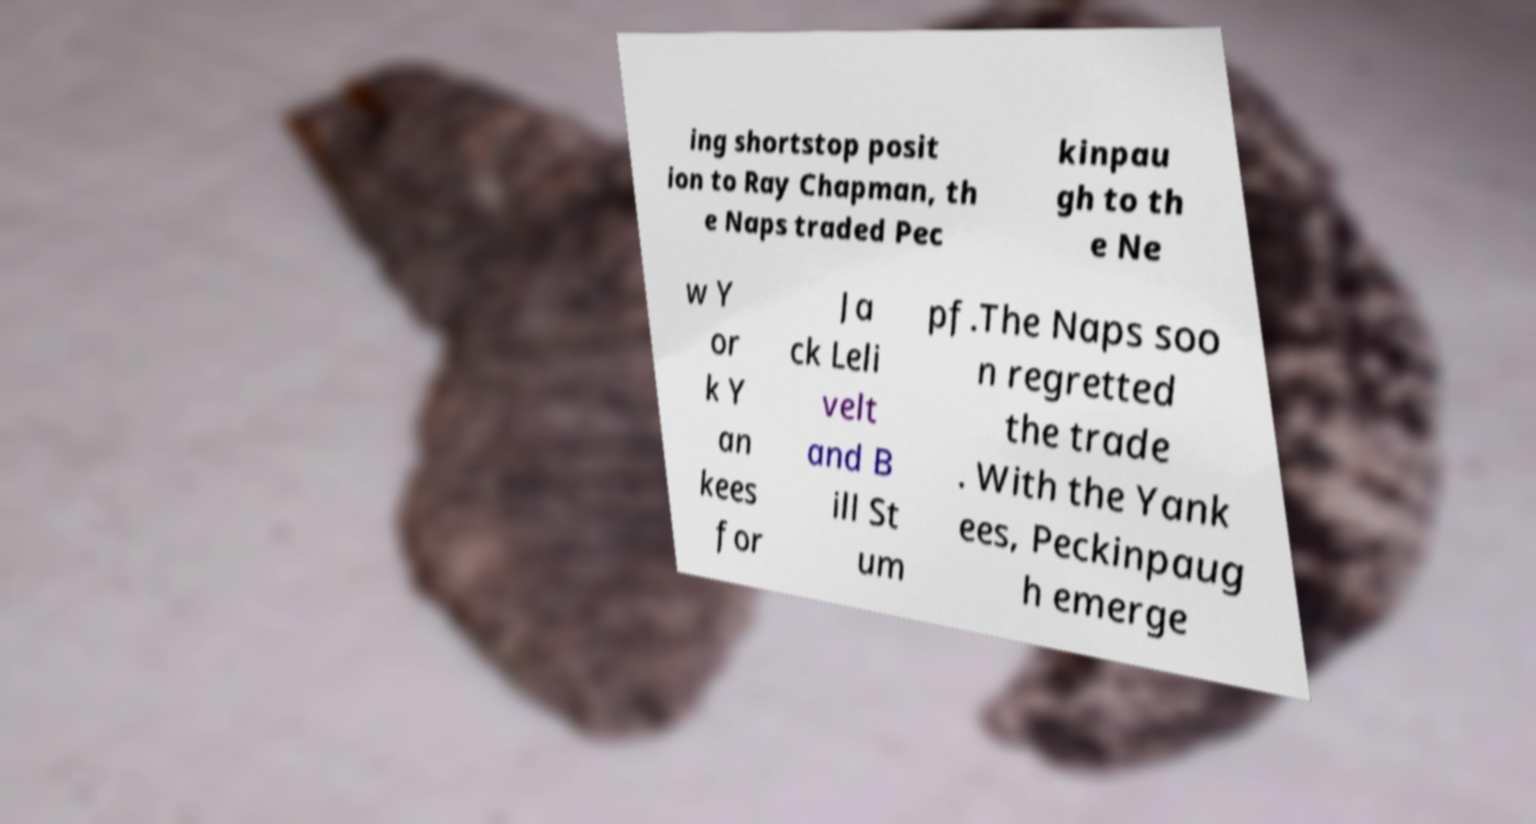There's text embedded in this image that I need extracted. Can you transcribe it verbatim? ing shortstop posit ion to Ray Chapman, th e Naps traded Pec kinpau gh to th e Ne w Y or k Y an kees for Ja ck Leli velt and B ill St um pf.The Naps soo n regretted the trade . With the Yank ees, Peckinpaug h emerge 